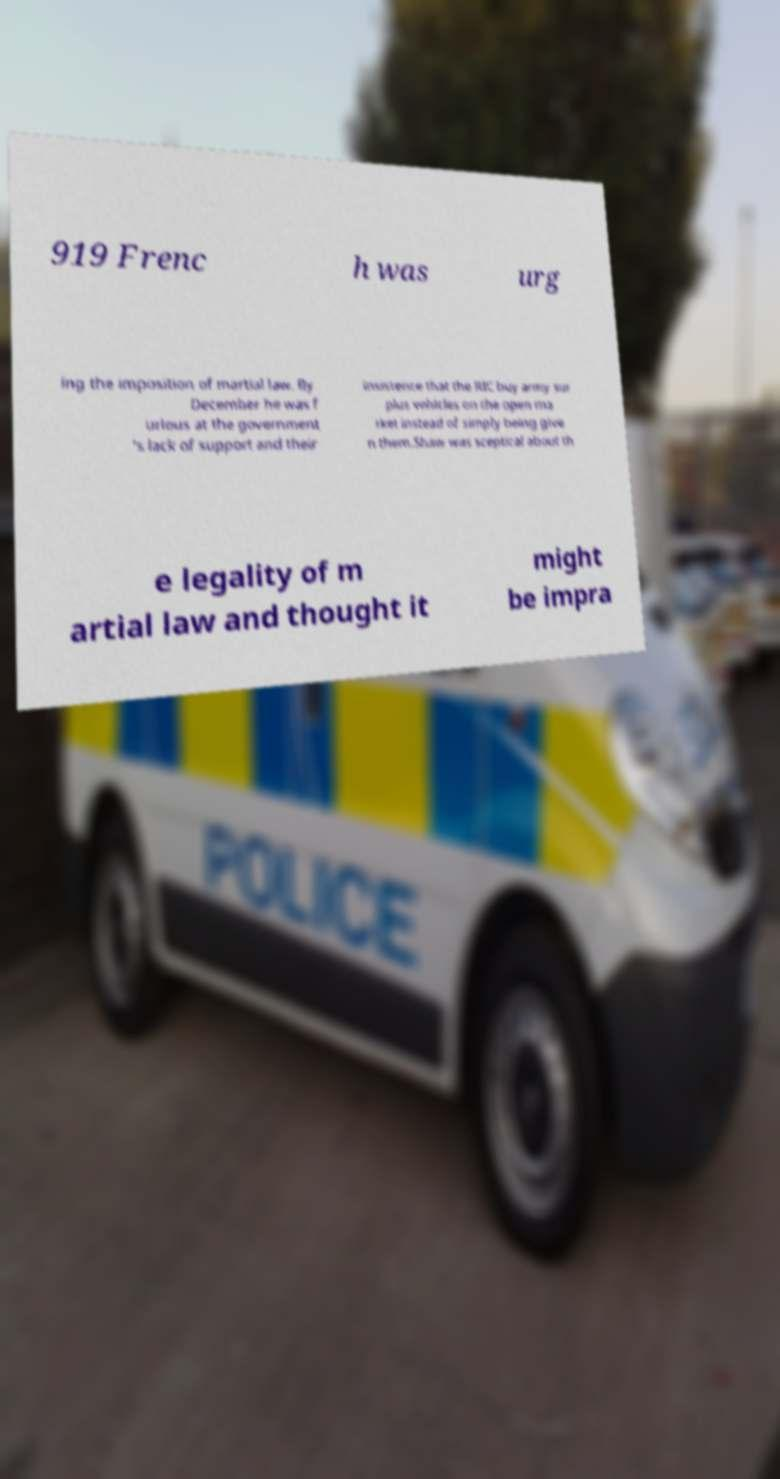There's text embedded in this image that I need extracted. Can you transcribe it verbatim? 919 Frenc h was urg ing the imposition of martial law. By December he was f urious at the government 's lack of support and their insistence that the RIC buy army sur plus vehicles on the open ma rket instead of simply being give n them.Shaw was sceptical about th e legality of m artial law and thought it might be impra 